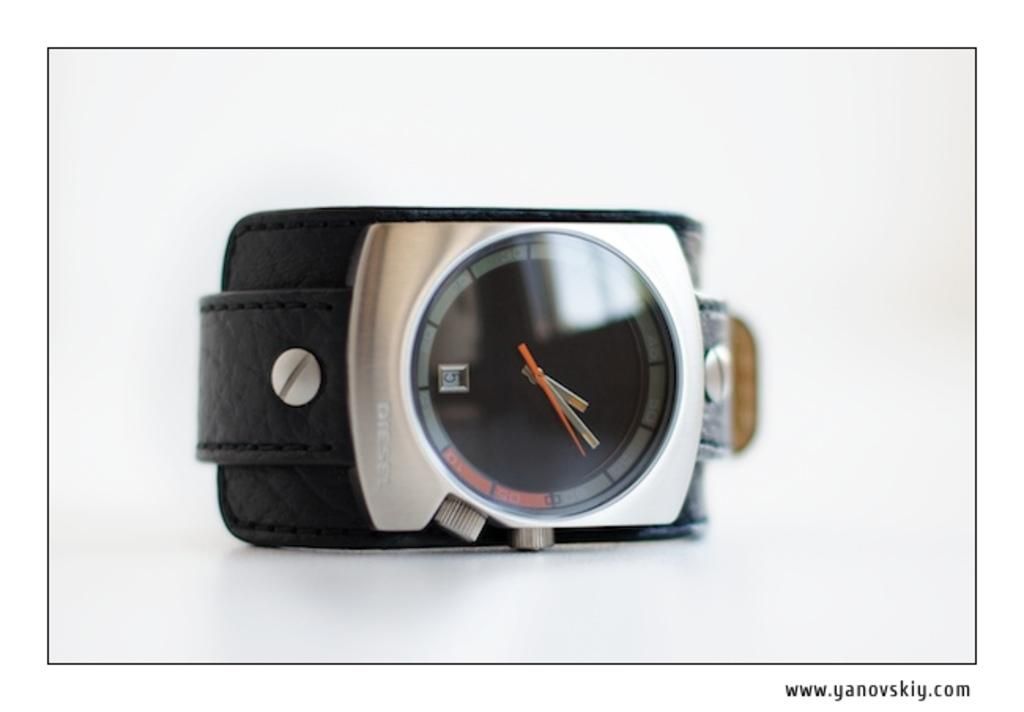<image>
Render a clear and concise summary of the photo. A wrist watch shows the time 1:09 with a small number 5 in the glass window above the six mark. 